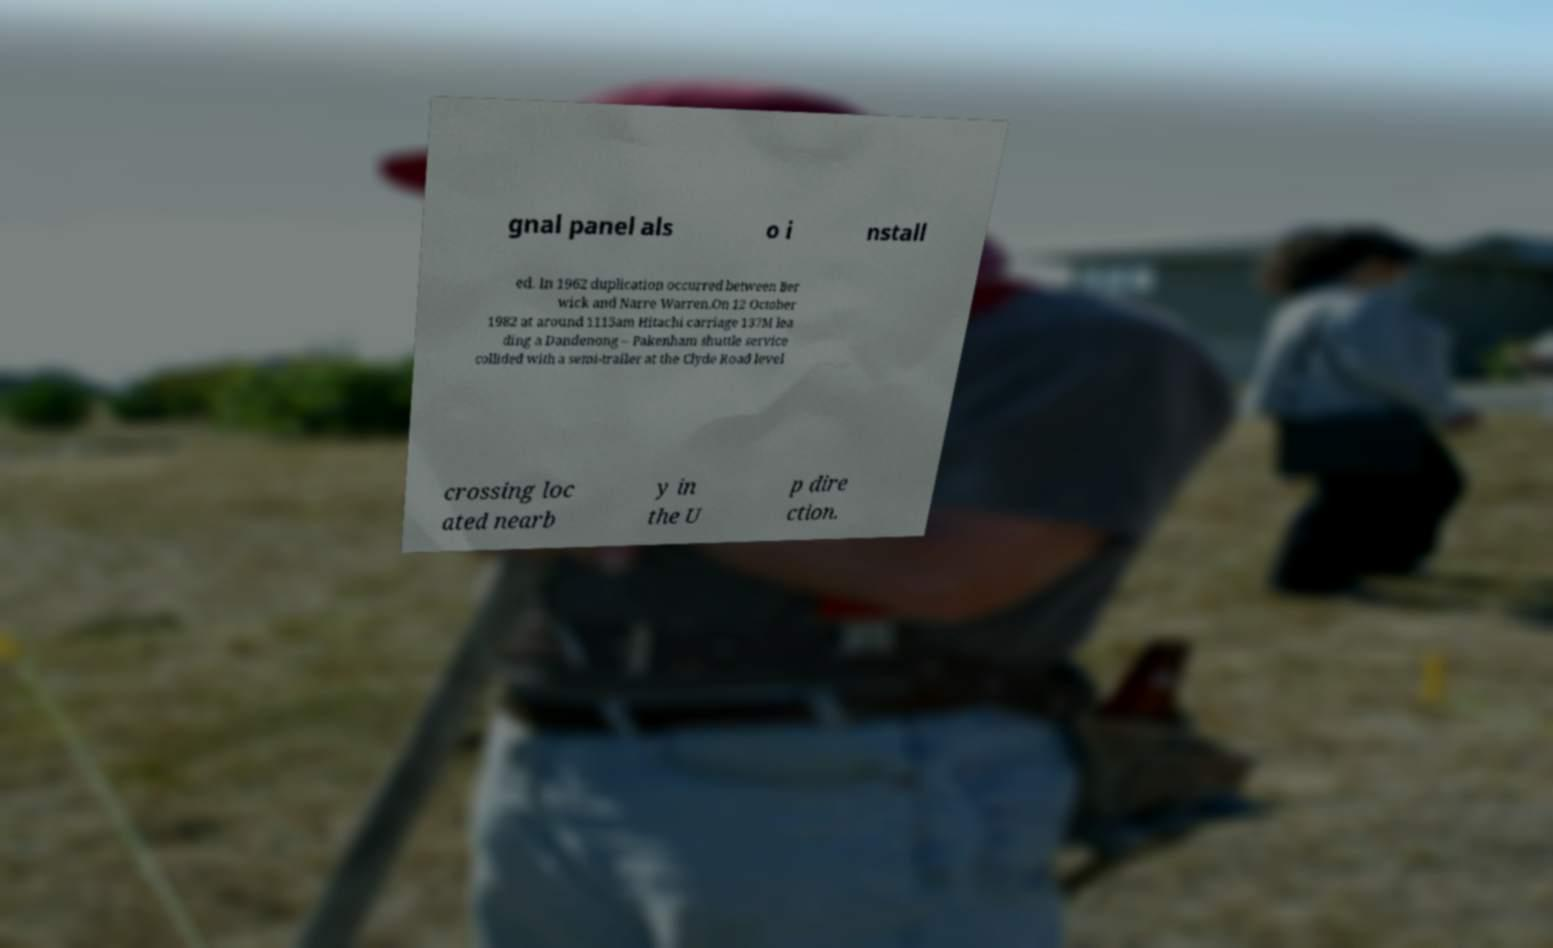Please identify and transcribe the text found in this image. gnal panel als o i nstall ed. In 1962 duplication occurred between Ber wick and Narre Warren.On 12 October 1982 at around 1115am Hitachi carriage 137M lea ding a Dandenong – Pakenham shuttle service collided with a semi-trailer at the Clyde Road level crossing loc ated nearb y in the U p dire ction. 